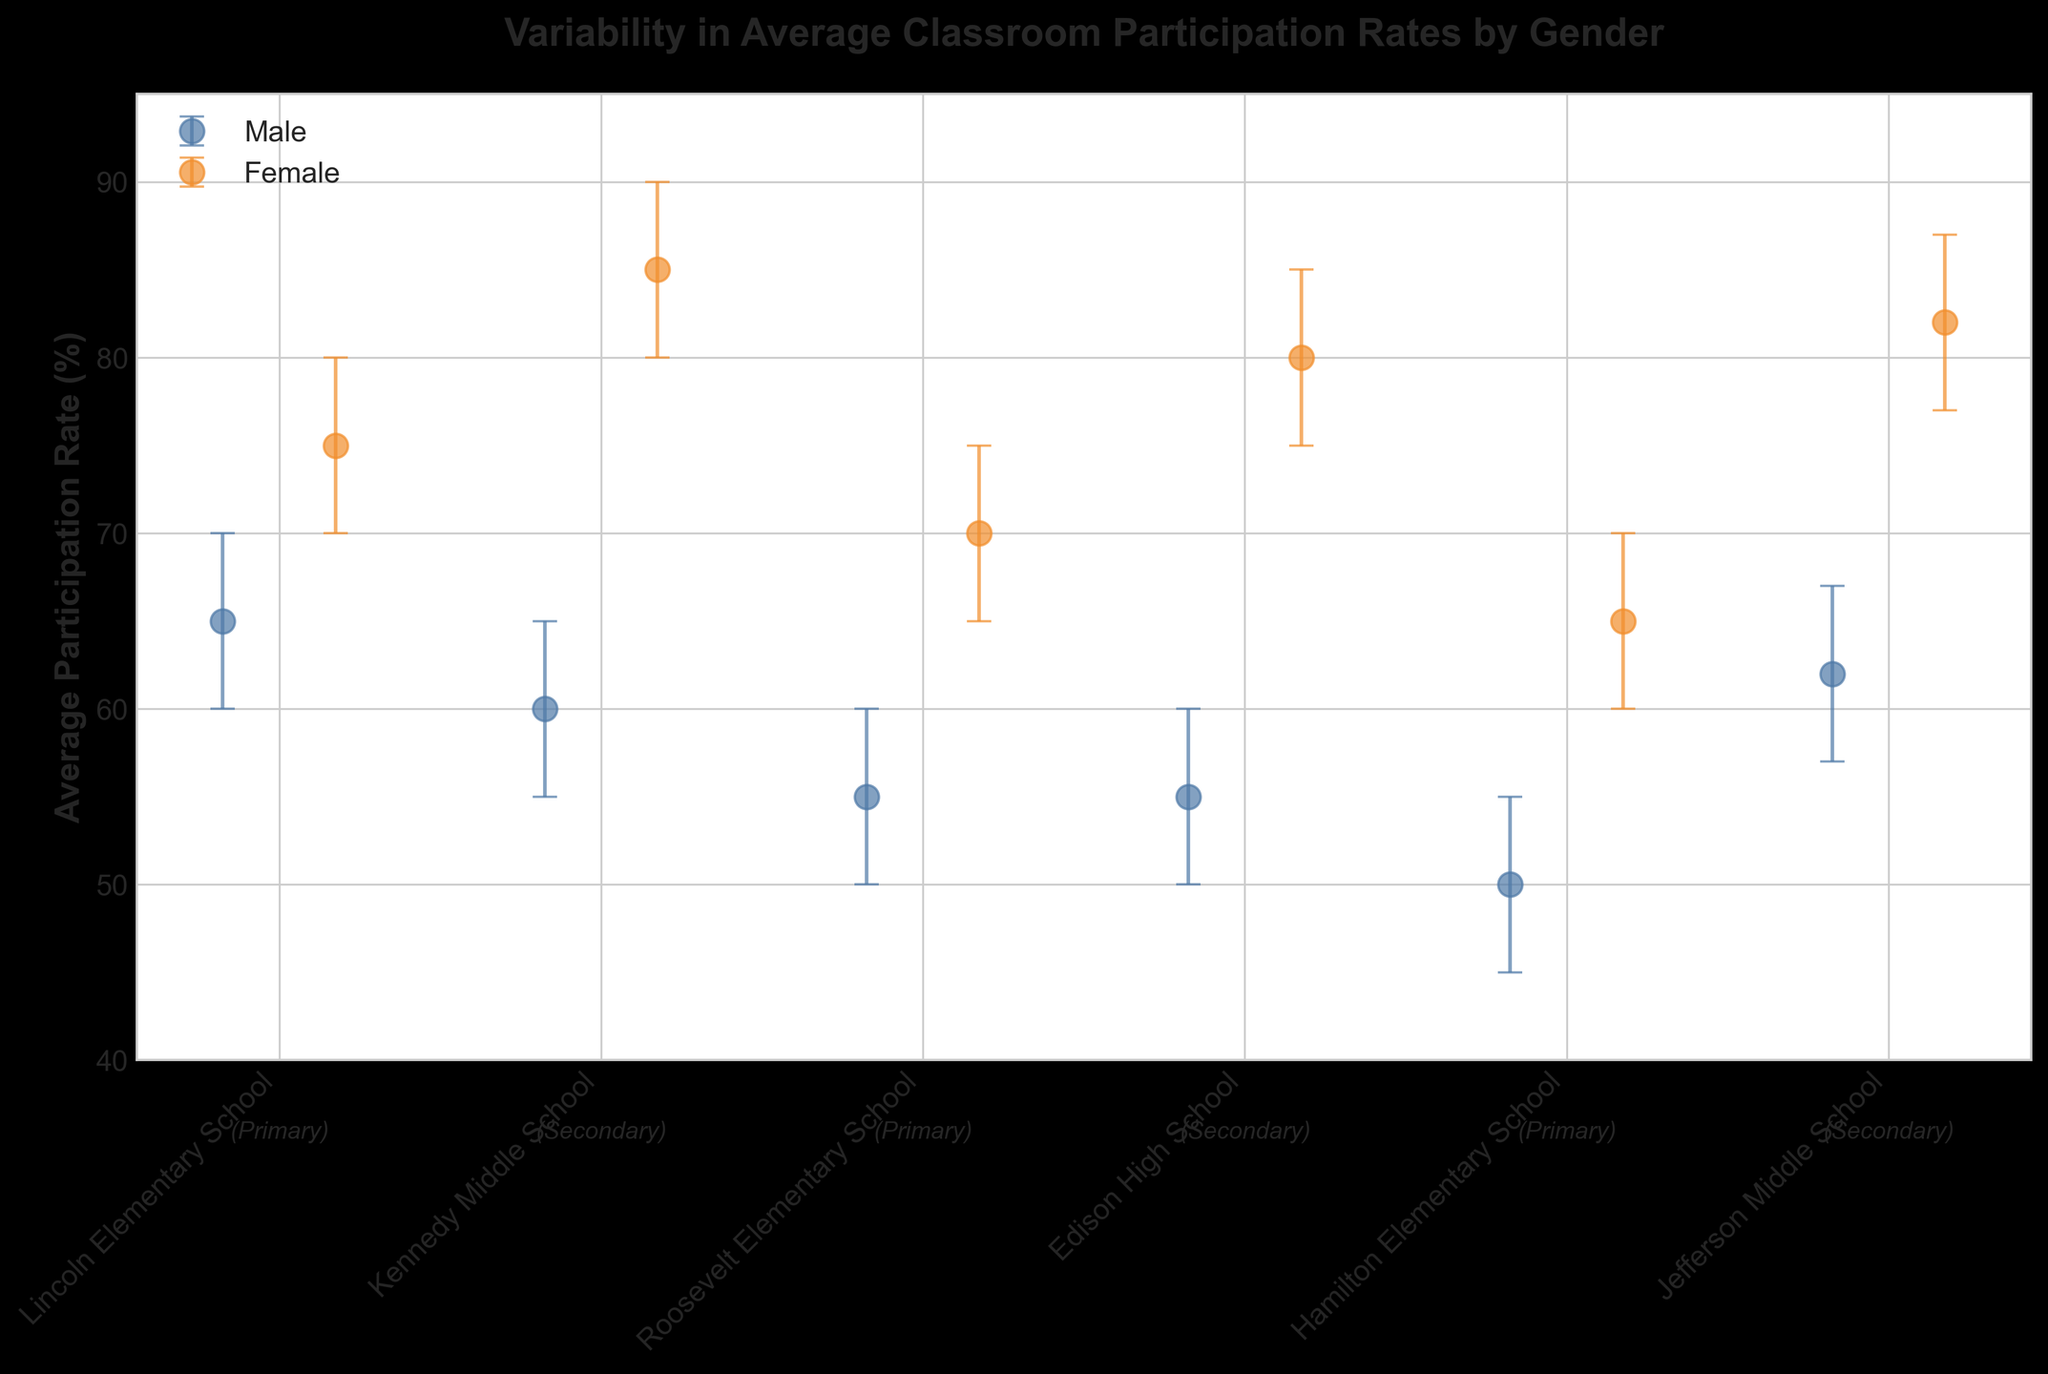What is the title of the plot? The title of the plot can be found at the top. It is usually a brief description summarizing what the plot represents.
Answer: Variability in Average Classroom Participation Rates by Gender What are the participation rates for females in elementary schools? The participation rates for females in elementary schools can be seen at the points marked with a color and labeled with the respective schools. There are three schools labeled as elementary.
Answer: 75, 70, 65 What elementary school has the lowest average participation rate for males? Look for the points representing males in the elementary schools, and identify the one with the lowest value on the y-axis.
Answer: Hamilton Elementary School What is the difference in average participation rates between males and females at Kennedy Middle School? Find the participation rates for both genders at Kennedy Middle School and calculate the difference. Males have 60% and females have 85%. 85% - 60% = 25%.
Answer: 25% Which school's male participation rate has the largest error bar? Compare the length of the error bars for males across all schools to determine which has the largest range.
Answer: Lincoln Elementary School Are participation rates generally higher for males or females in secondary schools? Compare the average participation rates by looking at the points for males and females in secondary schools. Females generally have higher participation rates.
Answer: Females Which elementary school has the smallest difference in participation rates between males and females? Calculate the differences in participation rates between males and females for each elementary school, and identify the smallest. Lincoln has a difference of 10%, Roosevelt has 15%, Hamilton has 15%. The smallest difference is at Lincoln.
Answer: Lincoln Elementary School How does Roosevelt Elementary School's female participation rate compare to Kennedy Middle School's female participation rate? Look at the participation rates for females at both schools and compare them. Roosevelt has 70% and Kennedy has 85%. 85% - 70% = 15%. Thus, Kennedy's rate is higher by 15%.
Answer: Kennedy Middle School is higher by 15% What is the range of participation rates for males in secondary schools? Identify the highest and lowest participation rates for males in secondary schools and calculate the range. Highest is 62% at Jefferson, lowest is 55% at Edison and Kennedy. The range is 62% - 55% = 7%.
Answer: 7% What pattern do you observe in the difference in participation rates between genders across all schools? Compare the differences in participation rates (Females - Males) across both primary and secondary schools to see if there is a consistent trend. Generally, females have higher participation rates, and the difference is more noticeable in secondary schools compared to primary schools.
Answer: Females have consistently higher rates; the difference is more pronounced in secondary schools 